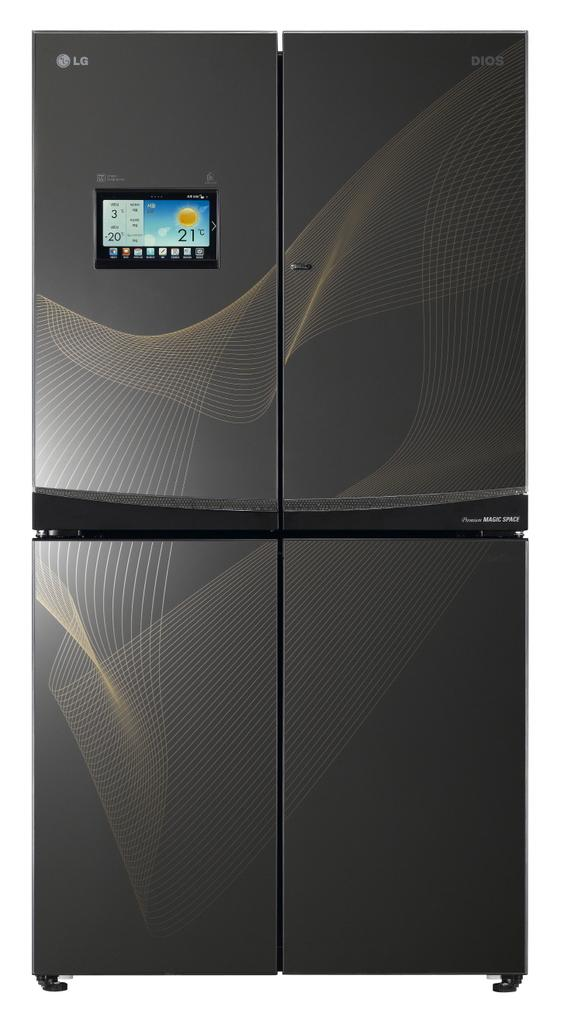<image>
Share a concise interpretation of the image provided. An LG fridge that has 4 different doors and lcd screen on it 